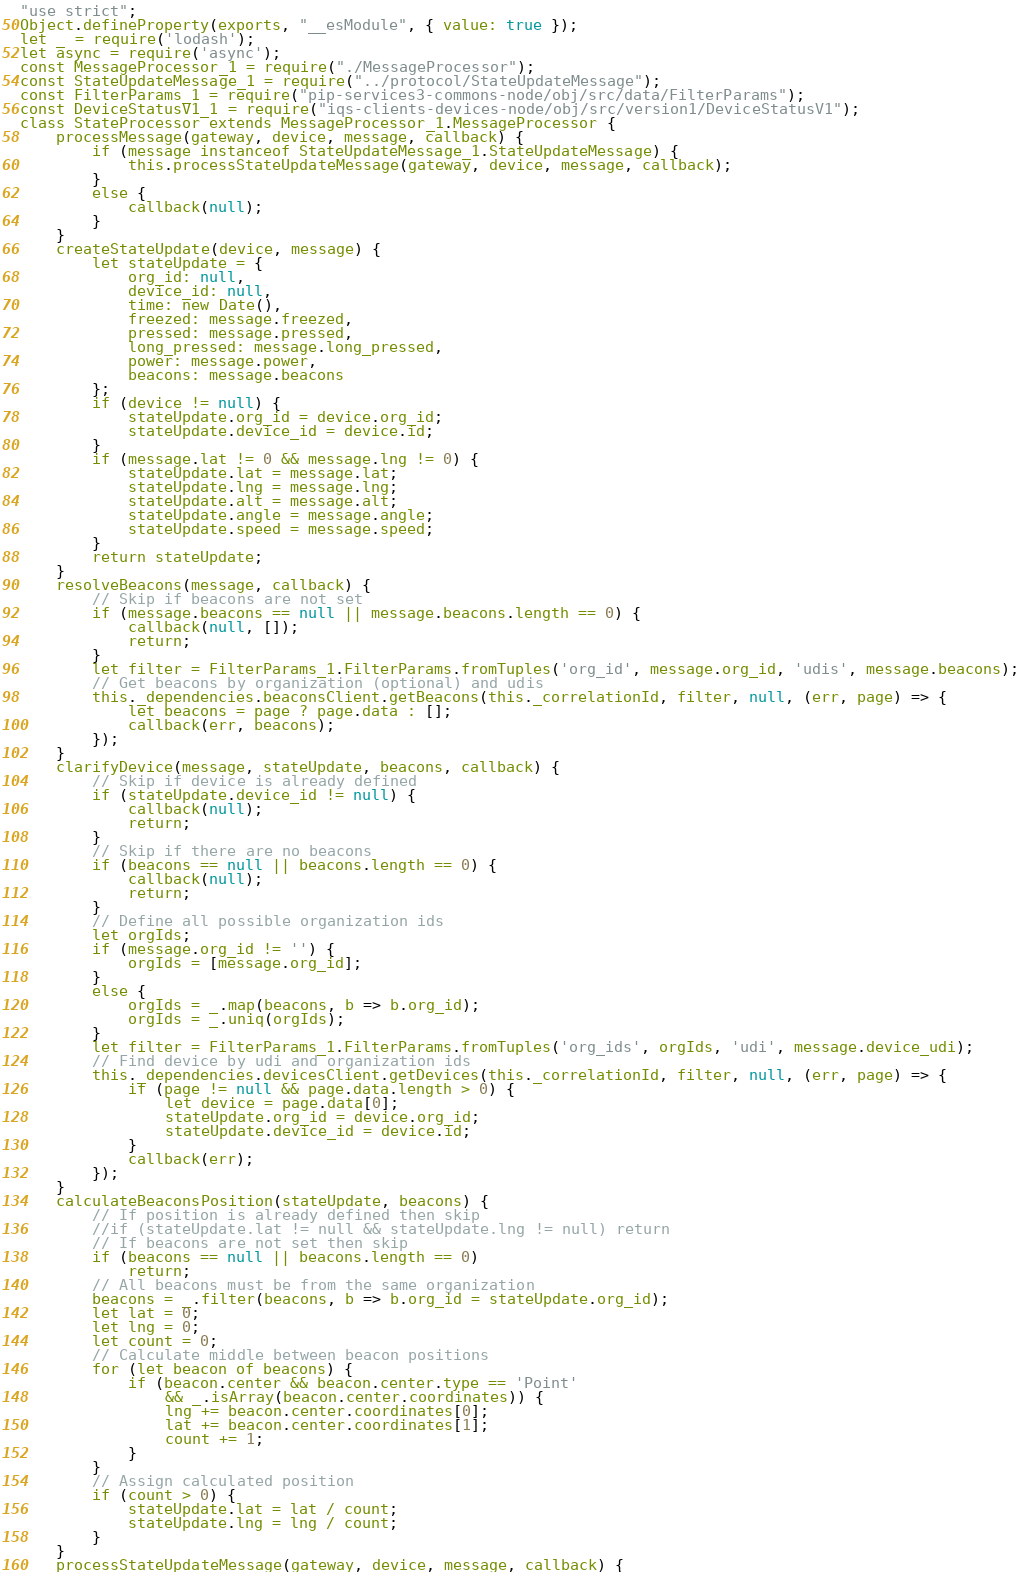<code> <loc_0><loc_0><loc_500><loc_500><_JavaScript_>"use strict";
Object.defineProperty(exports, "__esModule", { value: true });
let _ = require('lodash');
let async = require('async');
const MessageProcessor_1 = require("./MessageProcessor");
const StateUpdateMessage_1 = require("../protocol/StateUpdateMessage");
const FilterParams_1 = require("pip-services3-commons-node/obj/src/data/FilterParams");
const DeviceStatusV1_1 = require("iqs-clients-devices-node/obj/src/version1/DeviceStatusV1");
class StateProcessor extends MessageProcessor_1.MessageProcessor {
    processMessage(gateway, device, message, callback) {
        if (message instanceof StateUpdateMessage_1.StateUpdateMessage) {
            this.processStateUpdateMessage(gateway, device, message, callback);
        }
        else {
            callback(null);
        }
    }
    createStateUpdate(device, message) {
        let stateUpdate = {
            org_id: null,
            device_id: null,
            time: new Date(),
            freezed: message.freezed,
            pressed: message.pressed,
            long_pressed: message.long_pressed,
            power: message.power,
            beacons: message.beacons
        };
        if (device != null) {
            stateUpdate.org_id = device.org_id;
            stateUpdate.device_id = device.id;
        }
        if (message.lat != 0 && message.lng != 0) {
            stateUpdate.lat = message.lat;
            stateUpdate.lng = message.lng;
            stateUpdate.alt = message.alt;
            stateUpdate.angle = message.angle;
            stateUpdate.speed = message.speed;
        }
        return stateUpdate;
    }
    resolveBeacons(message, callback) {
        // Skip if beacons are not set
        if (message.beacons == null || message.beacons.length == 0) {
            callback(null, []);
            return;
        }
        let filter = FilterParams_1.FilterParams.fromTuples('org_id', message.org_id, 'udis', message.beacons);
        // Get beacons by organization (optional) and udis
        this._dependencies.beaconsClient.getBeacons(this._correlationId, filter, null, (err, page) => {
            let beacons = page ? page.data : [];
            callback(err, beacons);
        });
    }
    clarifyDevice(message, stateUpdate, beacons, callback) {
        // Skip if device is already defined
        if (stateUpdate.device_id != null) {
            callback(null);
            return;
        }
        // Skip if there are no beacons
        if (beacons == null || beacons.length == 0) {
            callback(null);
            return;
        }
        // Define all possible organization ids
        let orgIds;
        if (message.org_id != '') {
            orgIds = [message.org_id];
        }
        else {
            orgIds = _.map(beacons, b => b.org_id);
            orgIds = _.uniq(orgIds);
        }
        let filter = FilterParams_1.FilterParams.fromTuples('org_ids', orgIds, 'udi', message.device_udi);
        // Find device by udi and organization ids
        this._dependencies.devicesClient.getDevices(this._correlationId, filter, null, (err, page) => {
            if (page != null && page.data.length > 0) {
                let device = page.data[0];
                stateUpdate.org_id = device.org_id;
                stateUpdate.device_id = device.id;
            }
            callback(err);
        });
    }
    calculateBeaconsPosition(stateUpdate, beacons) {
        // If position is already defined then skip
        //if (stateUpdate.lat != null && stateUpdate.lng != null) return
        // If beacons are not set then skip
        if (beacons == null || beacons.length == 0)
            return;
        // All beacons must be from the same organization
        beacons = _.filter(beacons, b => b.org_id = stateUpdate.org_id);
        let lat = 0;
        let lng = 0;
        let count = 0;
        // Calculate middle between beacon positions
        for (let beacon of beacons) {
            if (beacon.center && beacon.center.type == 'Point'
                && _.isArray(beacon.center.coordinates)) {
                lng += beacon.center.coordinates[0];
                lat += beacon.center.coordinates[1];
                count += 1;
            }
        }
        // Assign calculated position
        if (count > 0) {
            stateUpdate.lat = lat / count;
            stateUpdate.lng = lng / count;
        }
    }
    processStateUpdateMessage(gateway, device, message, callback) {</code> 